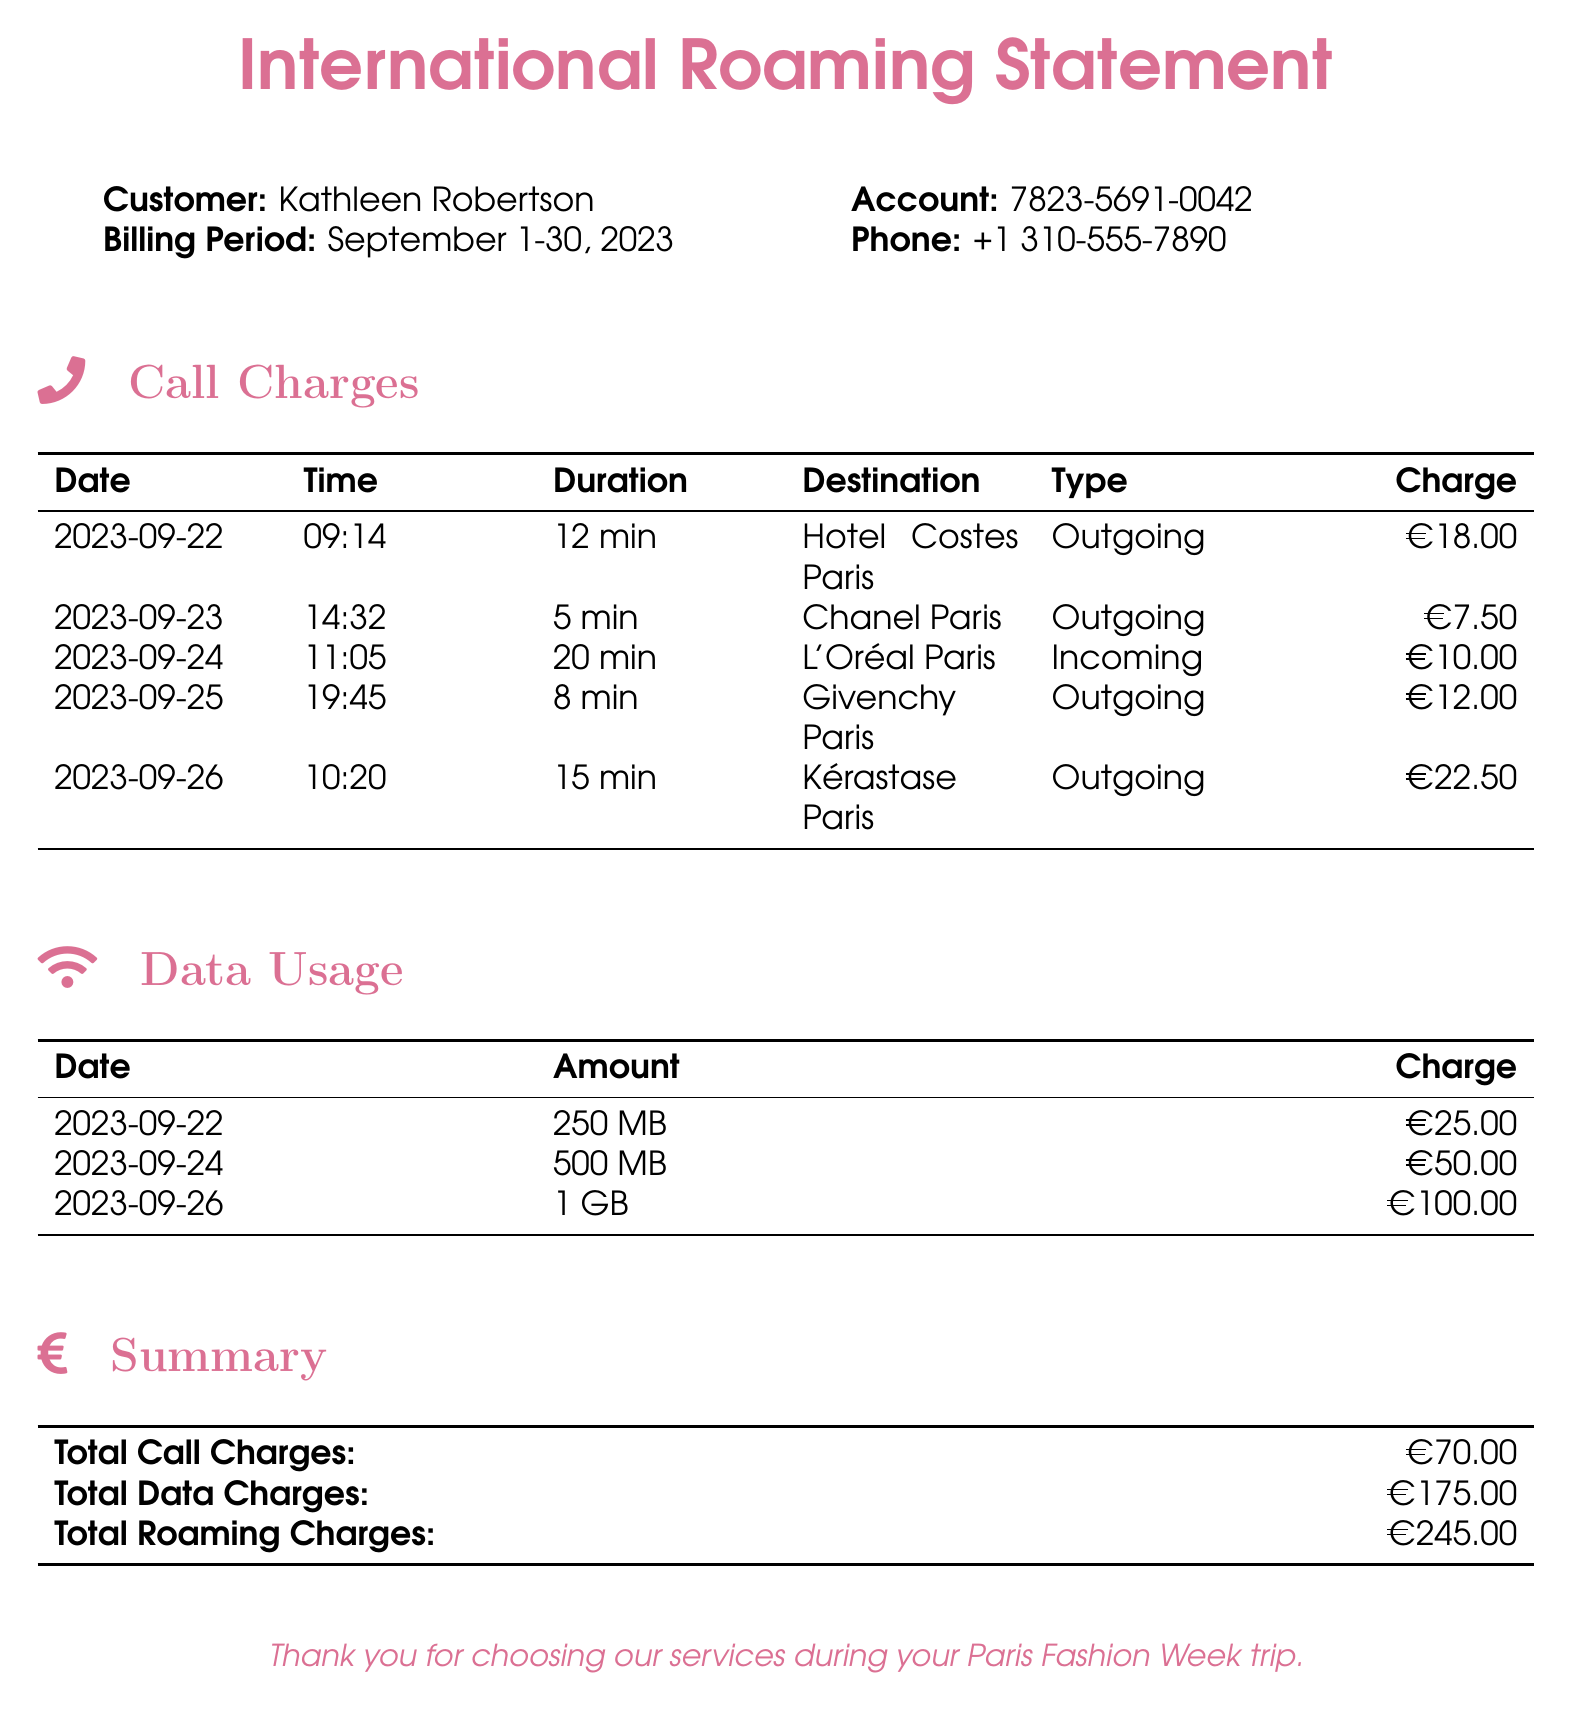What is the billing period? The billing period is specified in the document and indicates the time frame during which the charges occurred.
Answer: September 1-30, 2023 What is the total data charge? The total data charge is calculated from the individual data usage charges listed in the document.
Answer: €175.00 Who is the customer? The customer's name is provided in the document, identifying who incurred the charges.
Answer: Kathleen Robertson What was the charge for the call to Chanel Paris? The charge associated with the call to Chanel Paris is directly listed in the call charges table.
Answer: €7.50 How long was the call to Hotel Costes Paris? The duration of the call is specified in the call charges table.
Answer: 12 min What is the total roaming charge? The total roaming charge is the sum of total call charges and total data charges summarized at the end of the document.
Answer: €245.00 On what date was the call to L'Oréal Paris received? The specific date of the incoming call is documented within the call charges section.
Answer: 2023-09-24 What type of call was made to Givenchy Paris? The type of call is categorized in the call charges section of the document.
Answer: Outgoing What was the amount of data used on September 26? The amount of data used is listed under the data usage section for the corresponding date.
Answer: 1 GB 